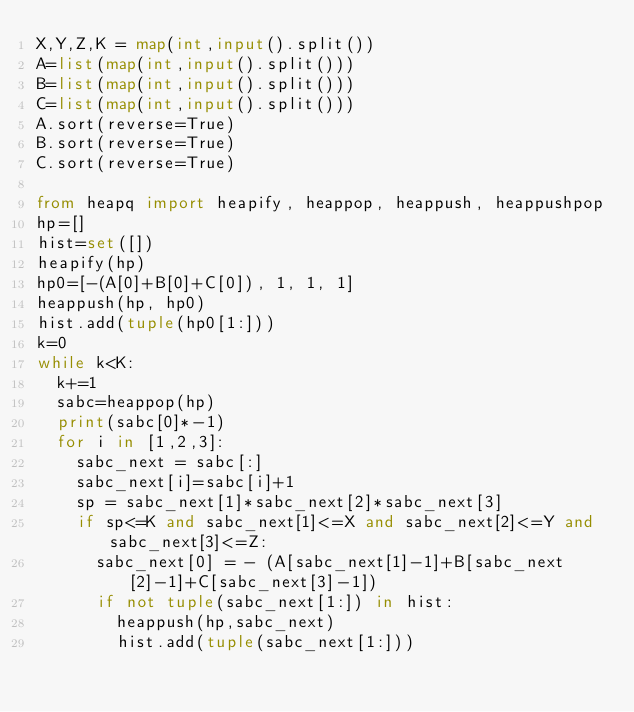<code> <loc_0><loc_0><loc_500><loc_500><_Python_>X,Y,Z,K = map(int,input().split())
A=list(map(int,input().split()))
B=list(map(int,input().split()))
C=list(map(int,input().split()))
A.sort(reverse=True)
B.sort(reverse=True)
C.sort(reverse=True)

from heapq import heapify, heappop, heappush, heappushpop
hp=[]
hist=set([])
heapify(hp)
hp0=[-(A[0]+B[0]+C[0]), 1, 1, 1]
heappush(hp, hp0)
hist.add(tuple(hp0[1:]))
k=0
while k<K:
  k+=1
  sabc=heappop(hp)
  print(sabc[0]*-1)
  for i in [1,2,3]:
    sabc_next = sabc[:]
    sabc_next[i]=sabc[i]+1
    sp = sabc_next[1]*sabc_next[2]*sabc_next[3]
    if sp<=K and sabc_next[1]<=X and sabc_next[2]<=Y and sabc_next[3]<=Z:
      sabc_next[0] = - (A[sabc_next[1]-1]+B[sabc_next[2]-1]+C[sabc_next[3]-1])
      if not tuple(sabc_next[1:]) in hist: 
        heappush(hp,sabc_next)
        hist.add(tuple(sabc_next[1:]))</code> 